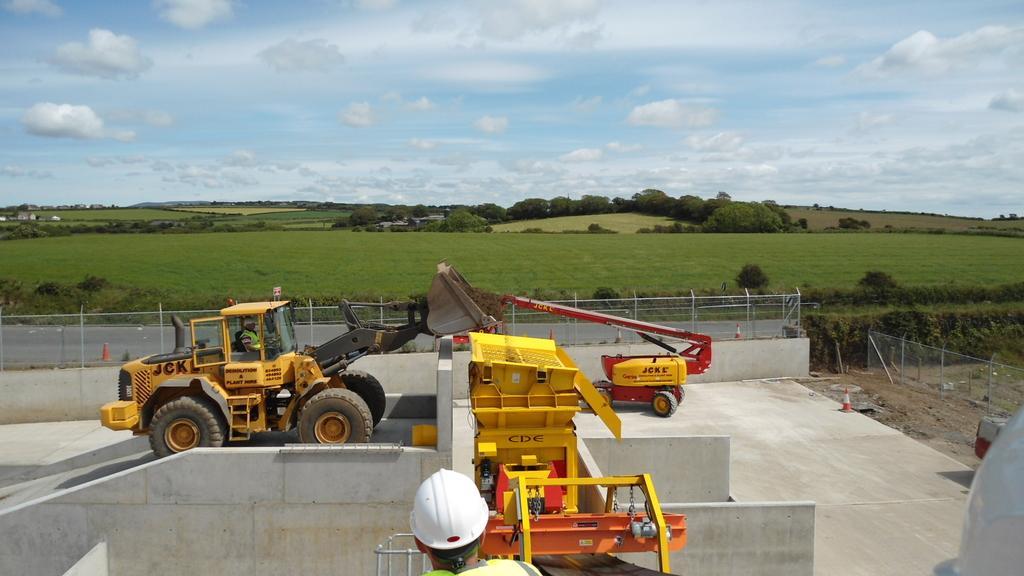How would you summarize this image in a sentence or two? In this image there are construction machines, in the background there is a field, trees and a cloudy sky. 